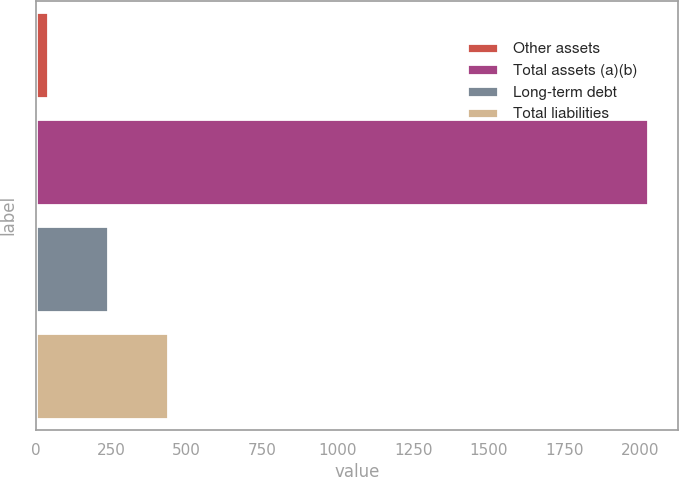<chart> <loc_0><loc_0><loc_500><loc_500><bar_chart><fcel>Other assets<fcel>Total assets (a)(b)<fcel>Long-term debt<fcel>Total liabilities<nl><fcel>41<fcel>2027<fcel>239.6<fcel>438.2<nl></chart> 